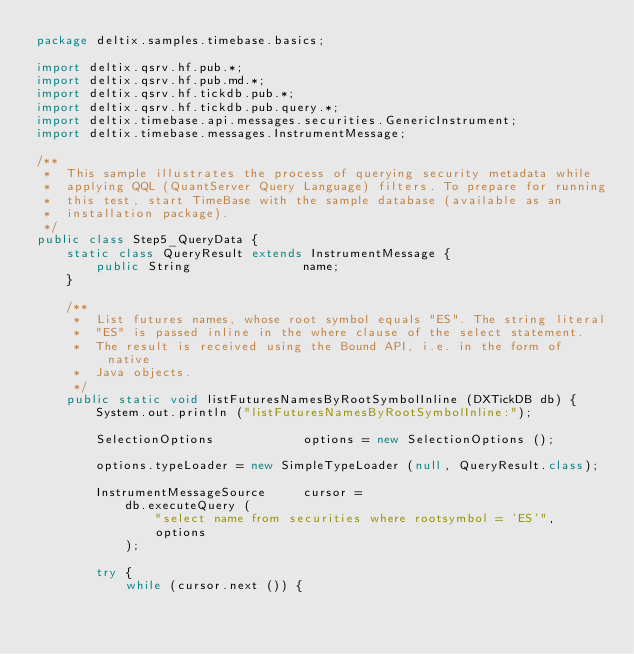<code> <loc_0><loc_0><loc_500><loc_500><_Java_>package deltix.samples.timebase.basics;

import deltix.qsrv.hf.pub.*;
import deltix.qsrv.hf.pub.md.*;
import deltix.qsrv.hf.tickdb.pub.*;
import deltix.qsrv.hf.tickdb.pub.query.*;
import deltix.timebase.api.messages.securities.GenericInstrument;
import deltix.timebase.messages.InstrumentMessage;

/**
 *  This sample illustrates the process of querying security metadata while
 *  applying QQL (QuantServer Query Language) filters. To prepare for running
 *  this test, start TimeBase with the sample database (available as an
 *  installation package).
 */
public class Step5_QueryData {
    static class QueryResult extends InstrumentMessage {
        public String               name;
    }

    /**
     *  List futures names, whose root symbol equals "ES". The string literal
     *  "ES" is passed inline in the where clause of the select statement.
     *  The result is received using the Bound API, i.e. in the form of native
     *  Java objects.
     */
    public static void listFuturesNamesByRootSymbolInline (DXTickDB db) {
        System.out.println ("listFuturesNamesByRootSymbolInline:");

        SelectionOptions            options = new SelectionOptions ();

        options.typeLoader = new SimpleTypeLoader (null, QueryResult.class);

        InstrumentMessageSource     cursor =
            db.executeQuery (
                "select name from securities where rootsymbol = 'ES'",
                options
            );

        try {
            while (cursor.next ()) {</code> 